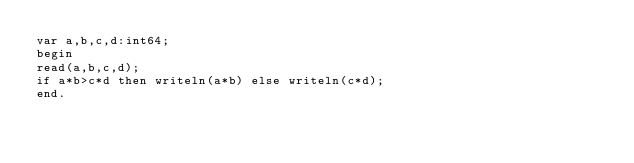Convert code to text. <code><loc_0><loc_0><loc_500><loc_500><_Pascal_>var a,b,c,d:int64;
begin
read(a,b,c,d);
if a*b>c*d then writeln(a*b) else writeln(c*d);
end.</code> 